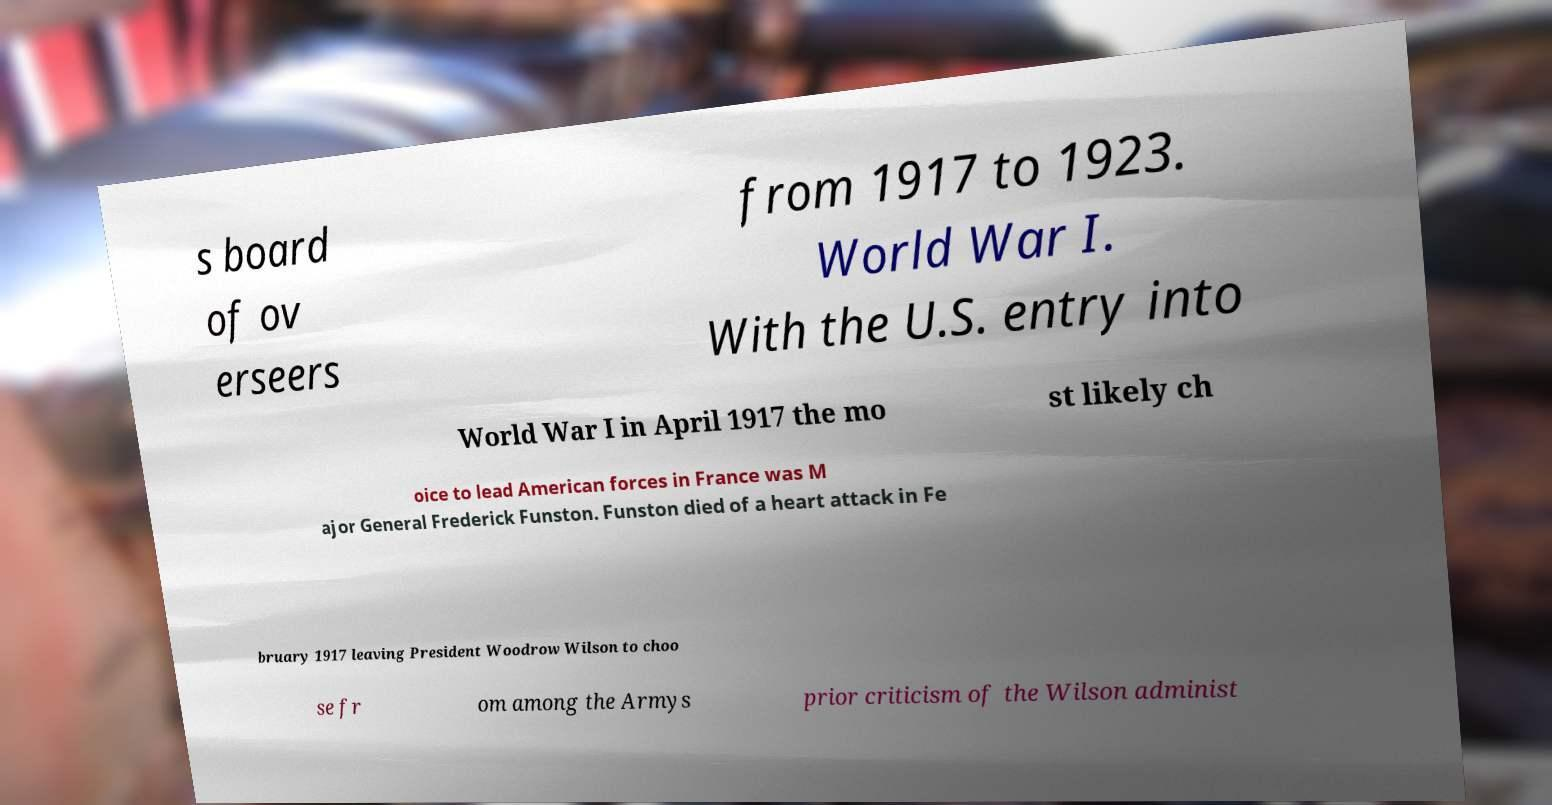I need the written content from this picture converted into text. Can you do that? s board of ov erseers from 1917 to 1923. World War I. With the U.S. entry into World War I in April 1917 the mo st likely ch oice to lead American forces in France was M ajor General Frederick Funston. Funston died of a heart attack in Fe bruary 1917 leaving President Woodrow Wilson to choo se fr om among the Armys prior criticism of the Wilson administ 